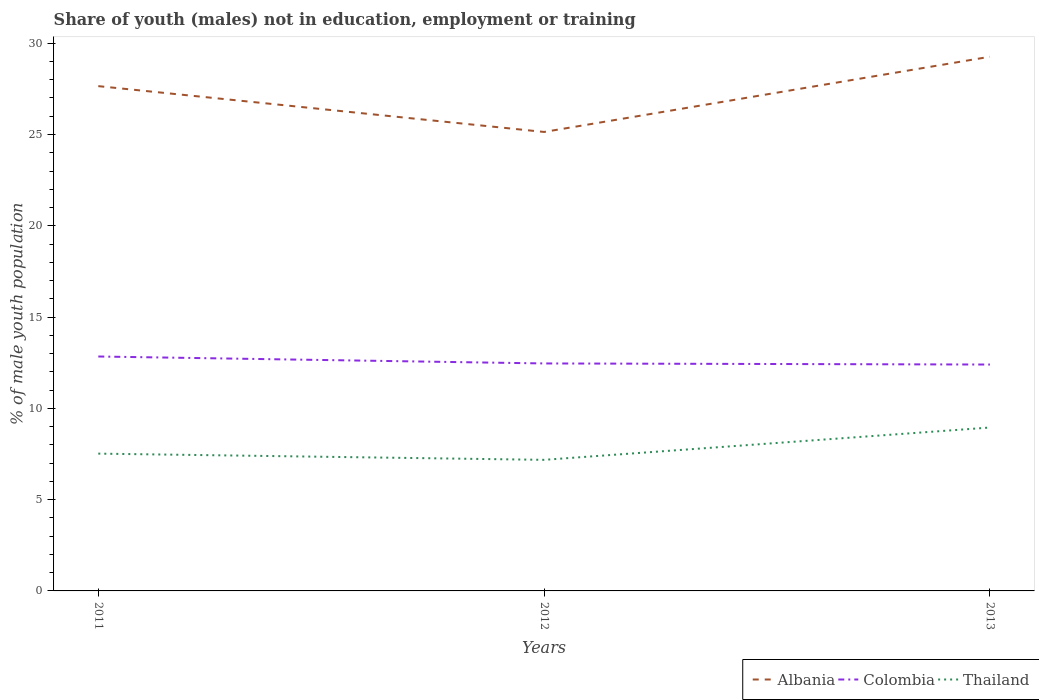How many different coloured lines are there?
Ensure brevity in your answer.  3. Across all years, what is the maximum percentage of unemployed males population in in Albania?
Offer a very short reply. 25.14. What is the total percentage of unemployed males population in in Thailand in the graph?
Your answer should be compact. -1.43. What is the difference between the highest and the second highest percentage of unemployed males population in in Colombia?
Offer a terse response. 0.44. Is the percentage of unemployed males population in in Albania strictly greater than the percentage of unemployed males population in in Colombia over the years?
Offer a terse response. No. How many years are there in the graph?
Make the answer very short. 3. Are the values on the major ticks of Y-axis written in scientific E-notation?
Provide a short and direct response. No. Does the graph contain any zero values?
Provide a succinct answer. No. How many legend labels are there?
Offer a very short reply. 3. What is the title of the graph?
Ensure brevity in your answer.  Share of youth (males) not in education, employment or training. What is the label or title of the Y-axis?
Give a very brief answer. % of male youth population. What is the % of male youth population in Albania in 2011?
Make the answer very short. 27.65. What is the % of male youth population of Colombia in 2011?
Ensure brevity in your answer.  12.84. What is the % of male youth population of Thailand in 2011?
Ensure brevity in your answer.  7.52. What is the % of male youth population of Albania in 2012?
Provide a succinct answer. 25.14. What is the % of male youth population of Colombia in 2012?
Your response must be concise. 12.46. What is the % of male youth population of Thailand in 2012?
Keep it short and to the point. 7.18. What is the % of male youth population of Albania in 2013?
Ensure brevity in your answer.  29.26. What is the % of male youth population in Colombia in 2013?
Ensure brevity in your answer.  12.4. What is the % of male youth population in Thailand in 2013?
Provide a succinct answer. 8.95. Across all years, what is the maximum % of male youth population of Albania?
Your answer should be very brief. 29.26. Across all years, what is the maximum % of male youth population of Colombia?
Offer a terse response. 12.84. Across all years, what is the maximum % of male youth population of Thailand?
Offer a terse response. 8.95. Across all years, what is the minimum % of male youth population in Albania?
Provide a succinct answer. 25.14. Across all years, what is the minimum % of male youth population in Colombia?
Provide a succinct answer. 12.4. Across all years, what is the minimum % of male youth population in Thailand?
Your response must be concise. 7.18. What is the total % of male youth population in Albania in the graph?
Make the answer very short. 82.05. What is the total % of male youth population in Colombia in the graph?
Your response must be concise. 37.7. What is the total % of male youth population of Thailand in the graph?
Offer a terse response. 23.65. What is the difference between the % of male youth population in Albania in 2011 and that in 2012?
Give a very brief answer. 2.51. What is the difference between the % of male youth population in Colombia in 2011 and that in 2012?
Keep it short and to the point. 0.38. What is the difference between the % of male youth population of Thailand in 2011 and that in 2012?
Make the answer very short. 0.34. What is the difference between the % of male youth population in Albania in 2011 and that in 2013?
Offer a very short reply. -1.61. What is the difference between the % of male youth population in Colombia in 2011 and that in 2013?
Make the answer very short. 0.44. What is the difference between the % of male youth population in Thailand in 2011 and that in 2013?
Give a very brief answer. -1.43. What is the difference between the % of male youth population of Albania in 2012 and that in 2013?
Give a very brief answer. -4.12. What is the difference between the % of male youth population in Thailand in 2012 and that in 2013?
Provide a succinct answer. -1.77. What is the difference between the % of male youth population of Albania in 2011 and the % of male youth population of Colombia in 2012?
Provide a short and direct response. 15.19. What is the difference between the % of male youth population of Albania in 2011 and the % of male youth population of Thailand in 2012?
Your answer should be very brief. 20.47. What is the difference between the % of male youth population of Colombia in 2011 and the % of male youth population of Thailand in 2012?
Provide a succinct answer. 5.66. What is the difference between the % of male youth population in Albania in 2011 and the % of male youth population in Colombia in 2013?
Make the answer very short. 15.25. What is the difference between the % of male youth population of Colombia in 2011 and the % of male youth population of Thailand in 2013?
Your answer should be compact. 3.89. What is the difference between the % of male youth population in Albania in 2012 and the % of male youth population in Colombia in 2013?
Ensure brevity in your answer.  12.74. What is the difference between the % of male youth population of Albania in 2012 and the % of male youth population of Thailand in 2013?
Offer a terse response. 16.19. What is the difference between the % of male youth population in Colombia in 2012 and the % of male youth population in Thailand in 2013?
Your answer should be compact. 3.51. What is the average % of male youth population in Albania per year?
Ensure brevity in your answer.  27.35. What is the average % of male youth population of Colombia per year?
Provide a short and direct response. 12.57. What is the average % of male youth population in Thailand per year?
Ensure brevity in your answer.  7.88. In the year 2011, what is the difference between the % of male youth population in Albania and % of male youth population in Colombia?
Ensure brevity in your answer.  14.81. In the year 2011, what is the difference between the % of male youth population in Albania and % of male youth population in Thailand?
Make the answer very short. 20.13. In the year 2011, what is the difference between the % of male youth population in Colombia and % of male youth population in Thailand?
Your answer should be very brief. 5.32. In the year 2012, what is the difference between the % of male youth population in Albania and % of male youth population in Colombia?
Your response must be concise. 12.68. In the year 2012, what is the difference between the % of male youth population of Albania and % of male youth population of Thailand?
Your answer should be very brief. 17.96. In the year 2012, what is the difference between the % of male youth population of Colombia and % of male youth population of Thailand?
Provide a short and direct response. 5.28. In the year 2013, what is the difference between the % of male youth population of Albania and % of male youth population of Colombia?
Keep it short and to the point. 16.86. In the year 2013, what is the difference between the % of male youth population of Albania and % of male youth population of Thailand?
Give a very brief answer. 20.31. In the year 2013, what is the difference between the % of male youth population of Colombia and % of male youth population of Thailand?
Your answer should be very brief. 3.45. What is the ratio of the % of male youth population in Albania in 2011 to that in 2012?
Keep it short and to the point. 1.1. What is the ratio of the % of male youth population of Colombia in 2011 to that in 2012?
Your response must be concise. 1.03. What is the ratio of the % of male youth population in Thailand in 2011 to that in 2012?
Keep it short and to the point. 1.05. What is the ratio of the % of male youth population in Albania in 2011 to that in 2013?
Keep it short and to the point. 0.94. What is the ratio of the % of male youth population in Colombia in 2011 to that in 2013?
Provide a succinct answer. 1.04. What is the ratio of the % of male youth population in Thailand in 2011 to that in 2013?
Offer a terse response. 0.84. What is the ratio of the % of male youth population in Albania in 2012 to that in 2013?
Your response must be concise. 0.86. What is the ratio of the % of male youth population of Thailand in 2012 to that in 2013?
Make the answer very short. 0.8. What is the difference between the highest and the second highest % of male youth population of Albania?
Your answer should be compact. 1.61. What is the difference between the highest and the second highest % of male youth population in Colombia?
Your answer should be compact. 0.38. What is the difference between the highest and the second highest % of male youth population of Thailand?
Provide a short and direct response. 1.43. What is the difference between the highest and the lowest % of male youth population of Albania?
Your response must be concise. 4.12. What is the difference between the highest and the lowest % of male youth population in Colombia?
Offer a terse response. 0.44. What is the difference between the highest and the lowest % of male youth population in Thailand?
Provide a short and direct response. 1.77. 